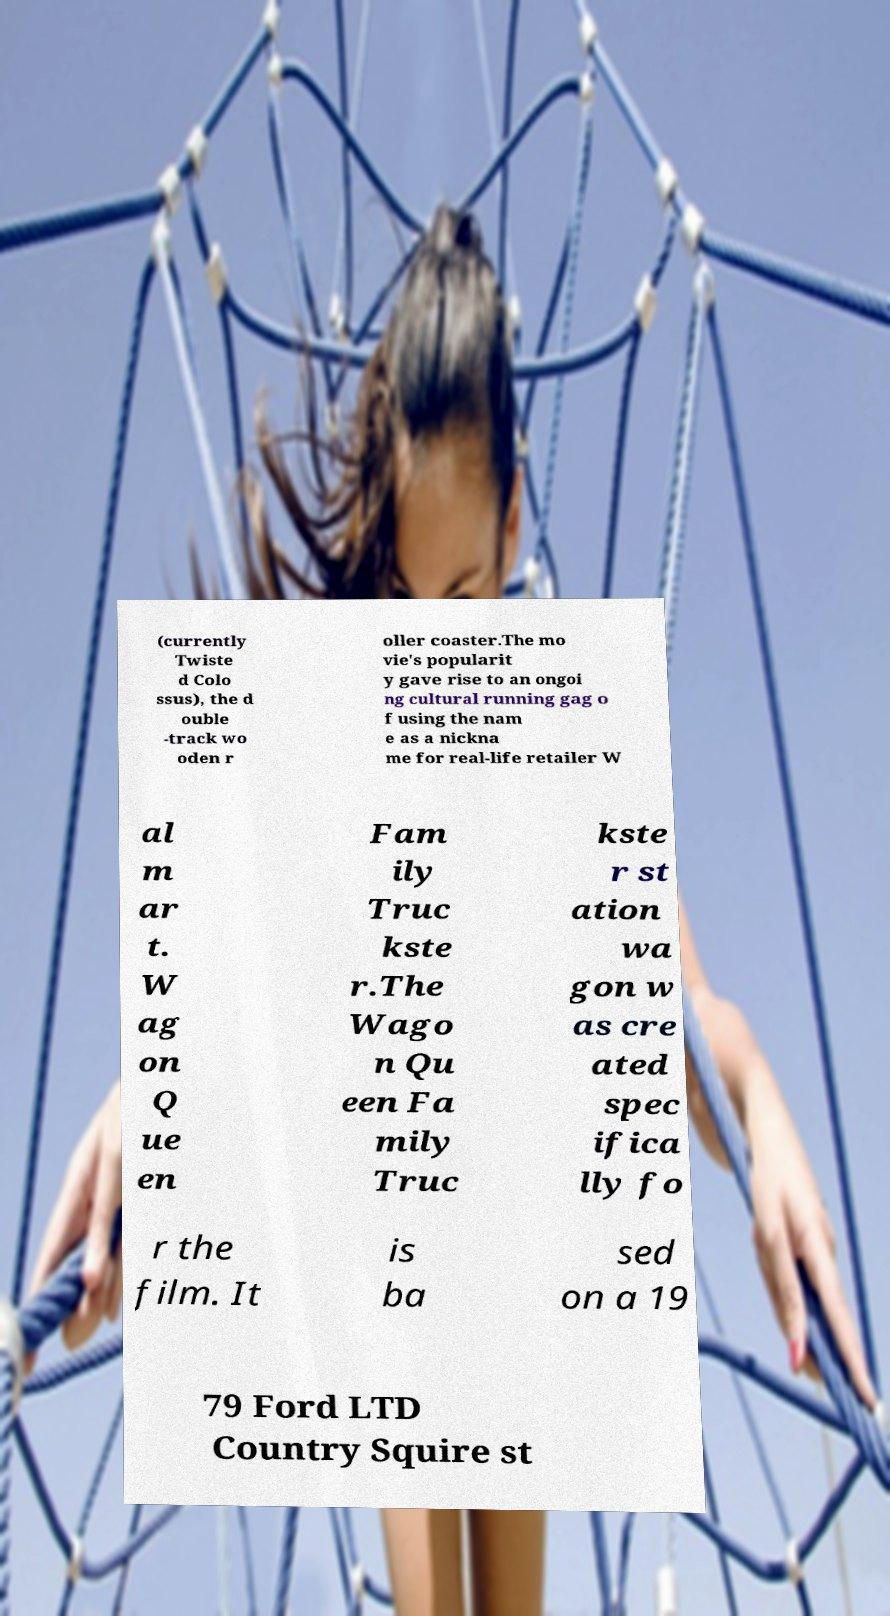For documentation purposes, I need the text within this image transcribed. Could you provide that? (currently Twiste d Colo ssus), the d ouble -track wo oden r oller coaster.The mo vie's popularit y gave rise to an ongoi ng cultural running gag o f using the nam e as a nickna me for real-life retailer W al m ar t. W ag on Q ue en Fam ily Truc kste r.The Wago n Qu een Fa mily Truc kste r st ation wa gon w as cre ated spec ifica lly fo r the film. It is ba sed on a 19 79 Ford LTD Country Squire st 